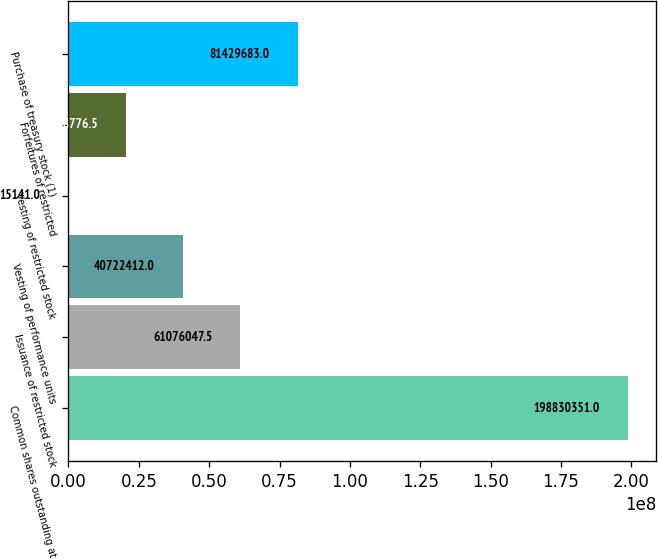Convert chart. <chart><loc_0><loc_0><loc_500><loc_500><bar_chart><fcel>Common shares outstanding at<fcel>Issuance of restricted stock<fcel>Vesting of performance units<fcel>Vesting of restricted stock<fcel>Forfeitures of restricted<fcel>Purchase of treasury stock (1)<nl><fcel>1.9883e+08<fcel>6.1076e+07<fcel>4.07224e+07<fcel>15141<fcel>2.03688e+07<fcel>8.14297e+07<nl></chart> 